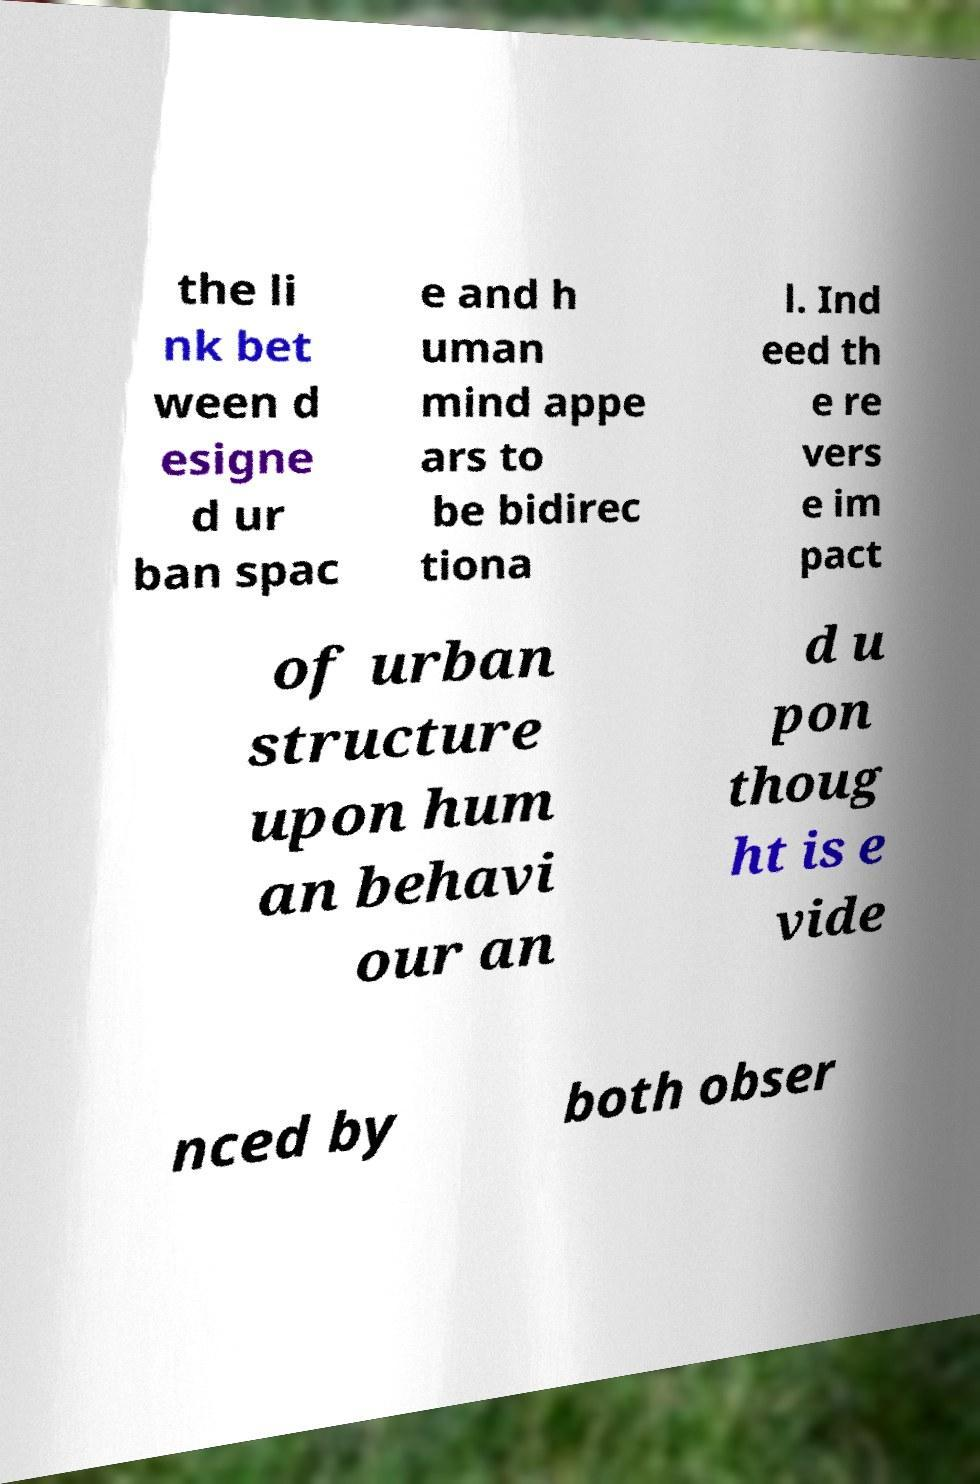What messages or text are displayed in this image? I need them in a readable, typed format. the li nk bet ween d esigne d ur ban spac e and h uman mind appe ars to be bidirec tiona l. Ind eed th e re vers e im pact of urban structure upon hum an behavi our an d u pon thoug ht is e vide nced by both obser 